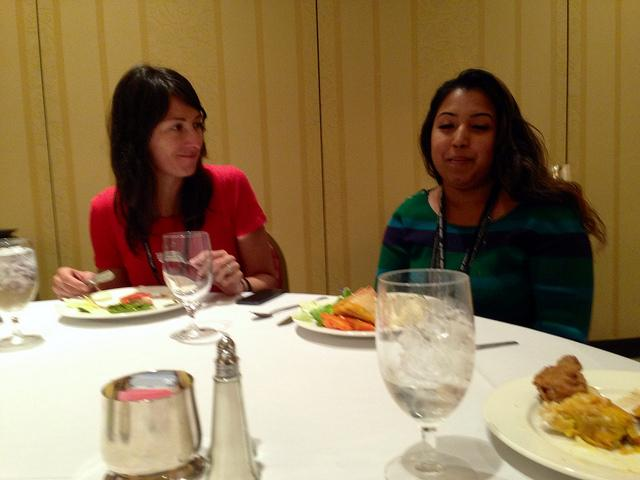What part of the meal is being eaten?

Choices:
A) soup
B) entree
C) salad
D) dessert entree 